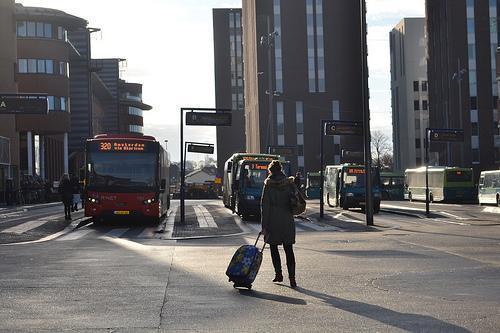How many people are in the picture?
Give a very brief answer. 2. 